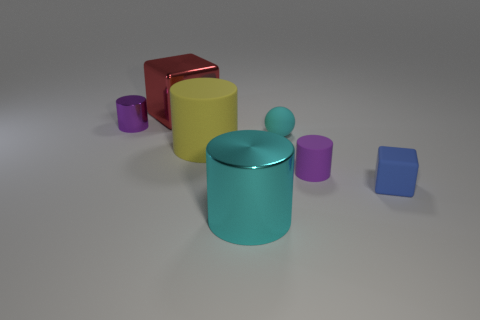There is a rubber thing that is the same color as the large metallic cylinder; what shape is it?
Ensure brevity in your answer.  Sphere. What number of yellow rubber objects are the same size as the red thing?
Offer a terse response. 1. Is there a object that is right of the big metal thing that is in front of the tiny blue block?
Offer a very short reply. Yes. What number of objects are either tiny purple metallic objects or large purple rubber blocks?
Provide a short and direct response. 1. There is a metallic object that is behind the tiny cylinder behind the small cyan matte sphere behind the large rubber object; what is its color?
Your response must be concise. Red. Is there any other thing that has the same color as the matte cube?
Ensure brevity in your answer.  No. Does the yellow cylinder have the same size as the cyan matte sphere?
Make the answer very short. No. How many objects are metallic cylinders in front of the small metallic thing or cylinders in front of the purple shiny cylinder?
Offer a very short reply. 3. What material is the block behind the purple matte object right of the large red shiny object?
Make the answer very short. Metal. What number of other things are the same material as the blue block?
Your response must be concise. 3. 